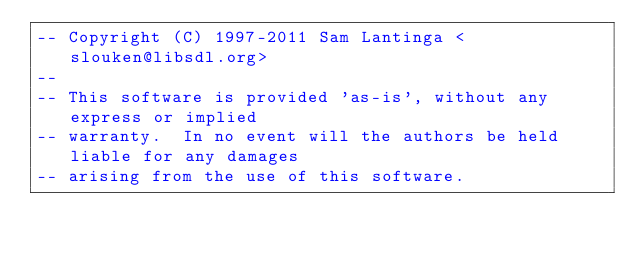Convert code to text. <code><loc_0><loc_0><loc_500><loc_500><_Lua_>-- Copyright (C) 1997-2011 Sam Lantinga <slouken@libsdl.org>
--
-- This software is provided 'as-is', without any express or implied
-- warranty.  In no event will the authors be held liable for any damages
-- arising from the use of this software.</code> 